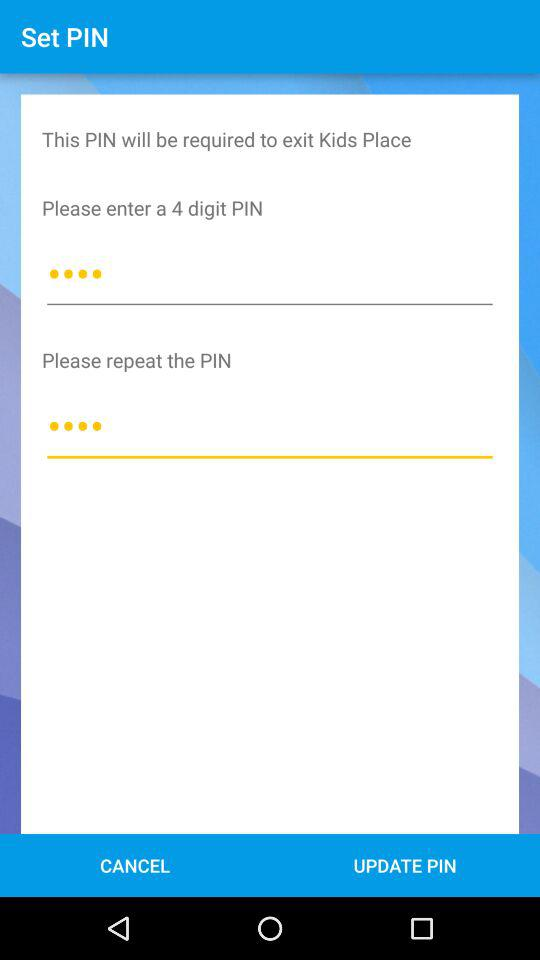What is the total number of digits in the PIN? The total number of digits in the PIN is 4. 